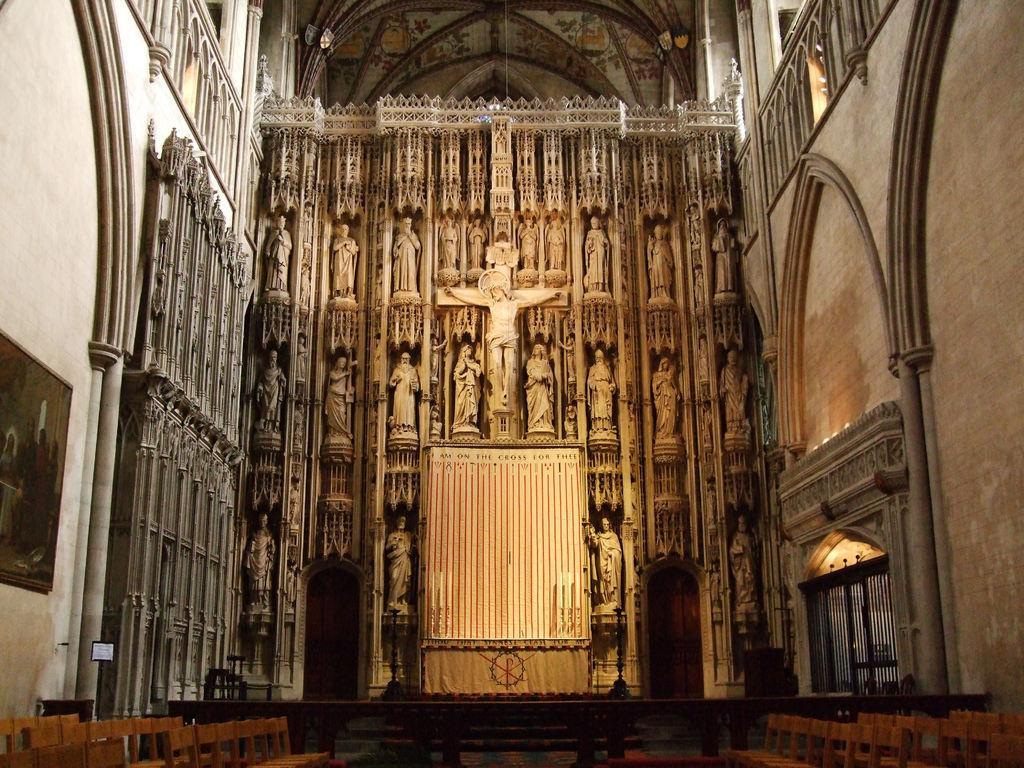Can you describe this image briefly? This picture is taken in the building. In this image, in the middle, we can see two sculptures. In the middle of the image, we can also see a statue standing on the wall. On the right side, we can see a wall, grill door. On the left side, we can also see some grills, pillar and a photo frame which is attached to a wall. In the background, we can see some sculptures. At the top, we can see a roof, at the bottom, we can see few benches. 